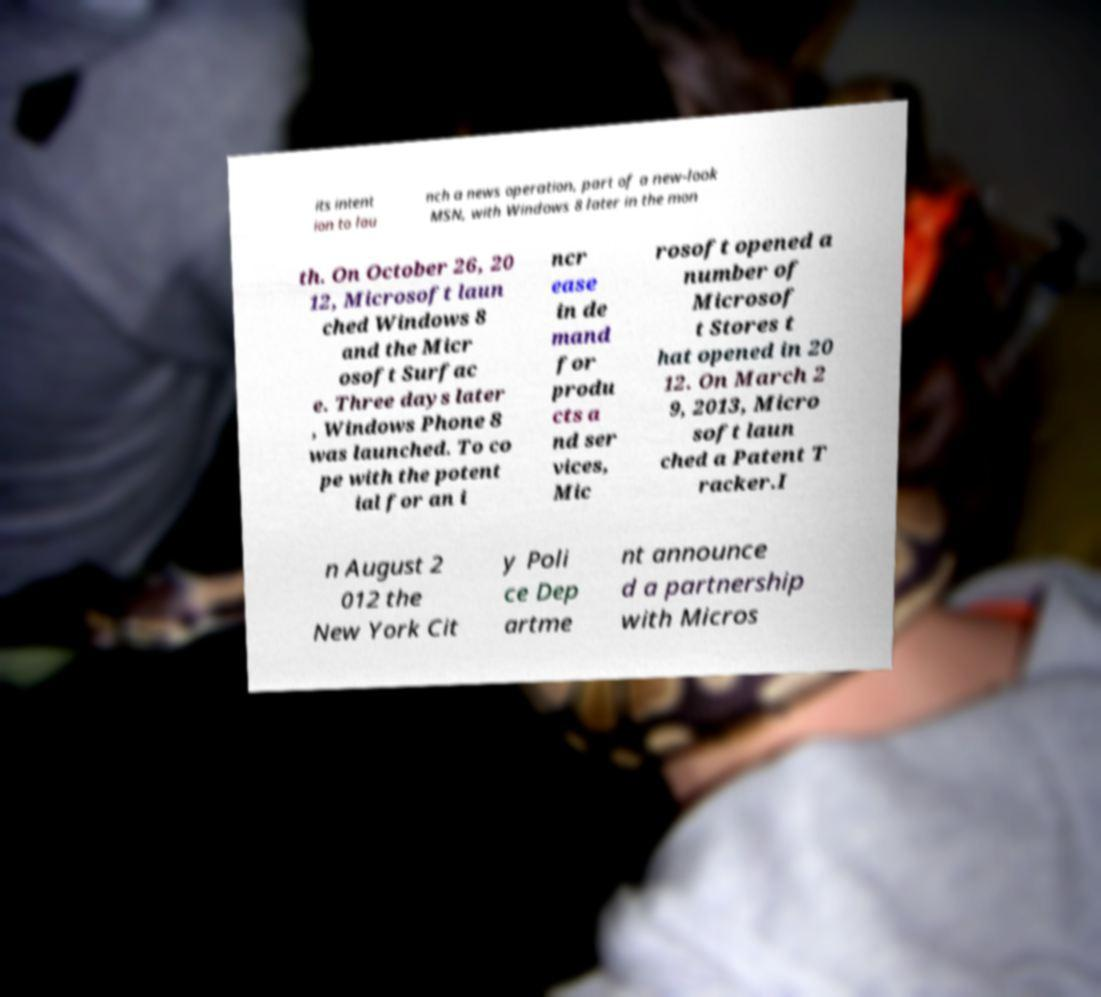Please identify and transcribe the text found in this image. its intent ion to lau nch a news operation, part of a new-look MSN, with Windows 8 later in the mon th. On October 26, 20 12, Microsoft laun ched Windows 8 and the Micr osoft Surfac e. Three days later , Windows Phone 8 was launched. To co pe with the potent ial for an i ncr ease in de mand for produ cts a nd ser vices, Mic rosoft opened a number of Microsof t Stores t hat opened in 20 12. On March 2 9, 2013, Micro soft laun ched a Patent T racker.I n August 2 012 the New York Cit y Poli ce Dep artme nt announce d a partnership with Micros 